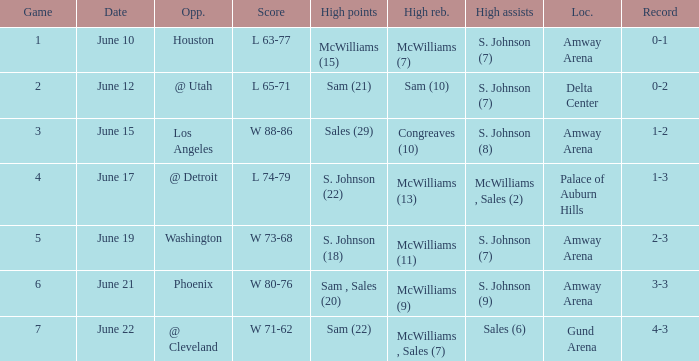Name the total number of date for  l 63-77 1.0. 